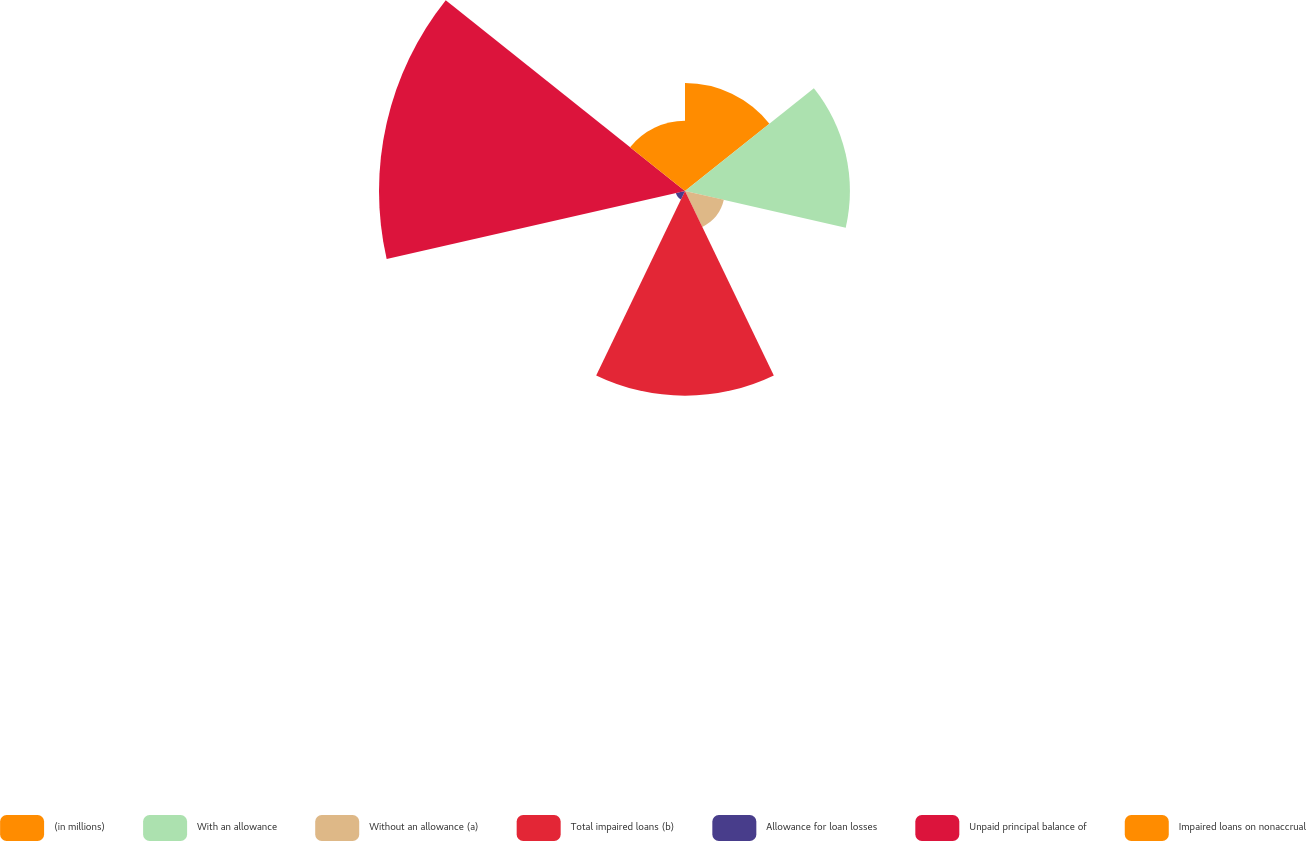<chart> <loc_0><loc_0><loc_500><loc_500><pie_chart><fcel>(in millions)<fcel>With an allowance<fcel>Without an allowance (a)<fcel>Total impaired loans (b)<fcel>Allowance for loan losses<fcel>Unpaid principal balance of<fcel>Impaired loans on nonaccrual<nl><fcel>11.96%<fcel>18.26%<fcel>4.41%<fcel>22.67%<fcel>1.03%<fcel>33.89%<fcel>7.78%<nl></chart> 